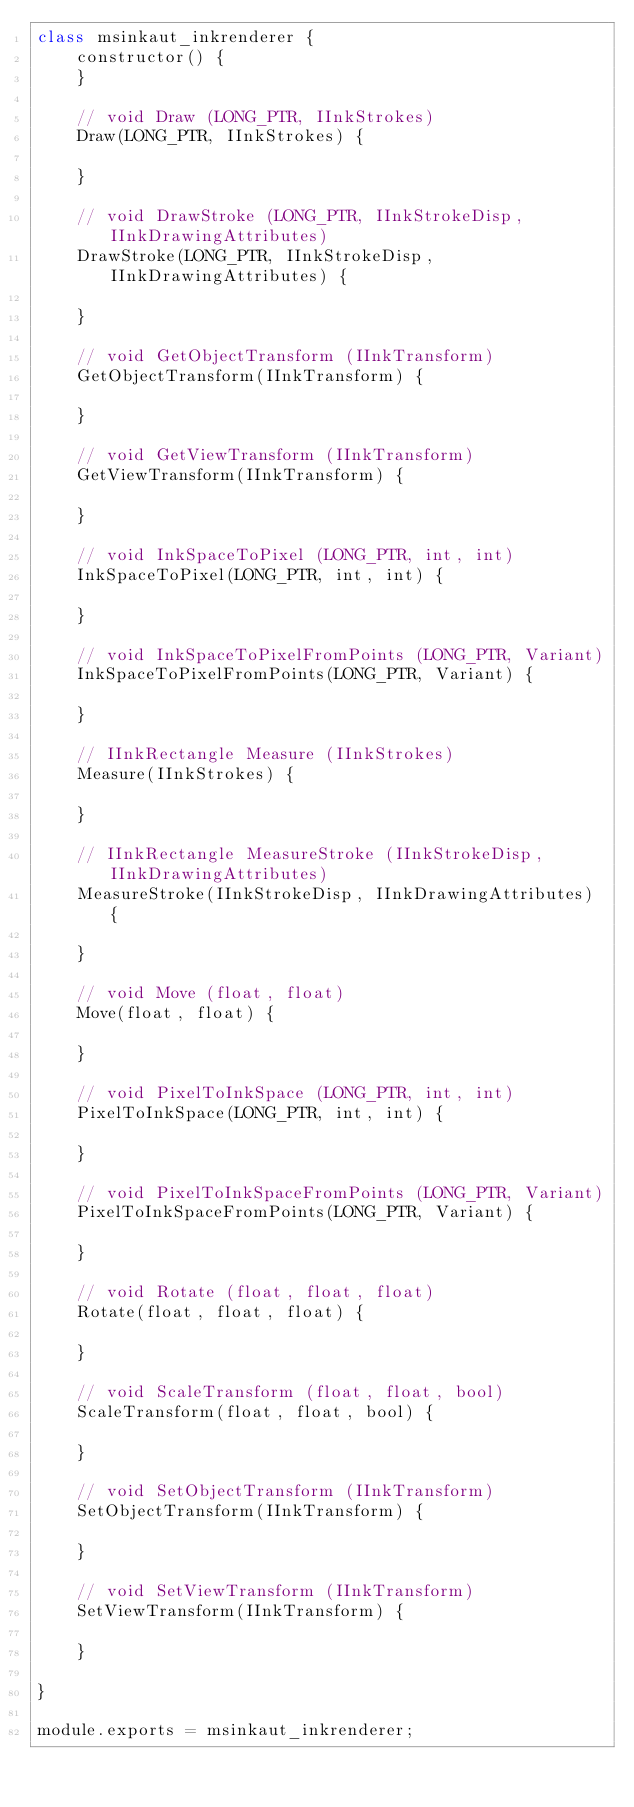Convert code to text. <code><loc_0><loc_0><loc_500><loc_500><_JavaScript_>class msinkaut_inkrenderer {
    constructor() {
    }

    // void Draw (LONG_PTR, IInkStrokes)
    Draw(LONG_PTR, IInkStrokes) {

    }

    // void DrawStroke (LONG_PTR, IInkStrokeDisp, IInkDrawingAttributes)
    DrawStroke(LONG_PTR, IInkStrokeDisp, IInkDrawingAttributes) {

    }

    // void GetObjectTransform (IInkTransform)
    GetObjectTransform(IInkTransform) {

    }

    // void GetViewTransform (IInkTransform)
    GetViewTransform(IInkTransform) {

    }

    // void InkSpaceToPixel (LONG_PTR, int, int)
    InkSpaceToPixel(LONG_PTR, int, int) {

    }

    // void InkSpaceToPixelFromPoints (LONG_PTR, Variant)
    InkSpaceToPixelFromPoints(LONG_PTR, Variant) {

    }

    // IInkRectangle Measure (IInkStrokes)
    Measure(IInkStrokes) {

    }

    // IInkRectangle MeasureStroke (IInkStrokeDisp, IInkDrawingAttributes)
    MeasureStroke(IInkStrokeDisp, IInkDrawingAttributes) {

    }

    // void Move (float, float)
    Move(float, float) {

    }

    // void PixelToInkSpace (LONG_PTR, int, int)
    PixelToInkSpace(LONG_PTR, int, int) {

    }

    // void PixelToInkSpaceFromPoints (LONG_PTR, Variant)
    PixelToInkSpaceFromPoints(LONG_PTR, Variant) {

    }

    // void Rotate (float, float, float)
    Rotate(float, float, float) {

    }

    // void ScaleTransform (float, float, bool)
    ScaleTransform(float, float, bool) {

    }

    // void SetObjectTransform (IInkTransform)
    SetObjectTransform(IInkTransform) {

    }

    // void SetViewTransform (IInkTransform)
    SetViewTransform(IInkTransform) {

    }

}

module.exports = msinkaut_inkrenderer;

</code> 